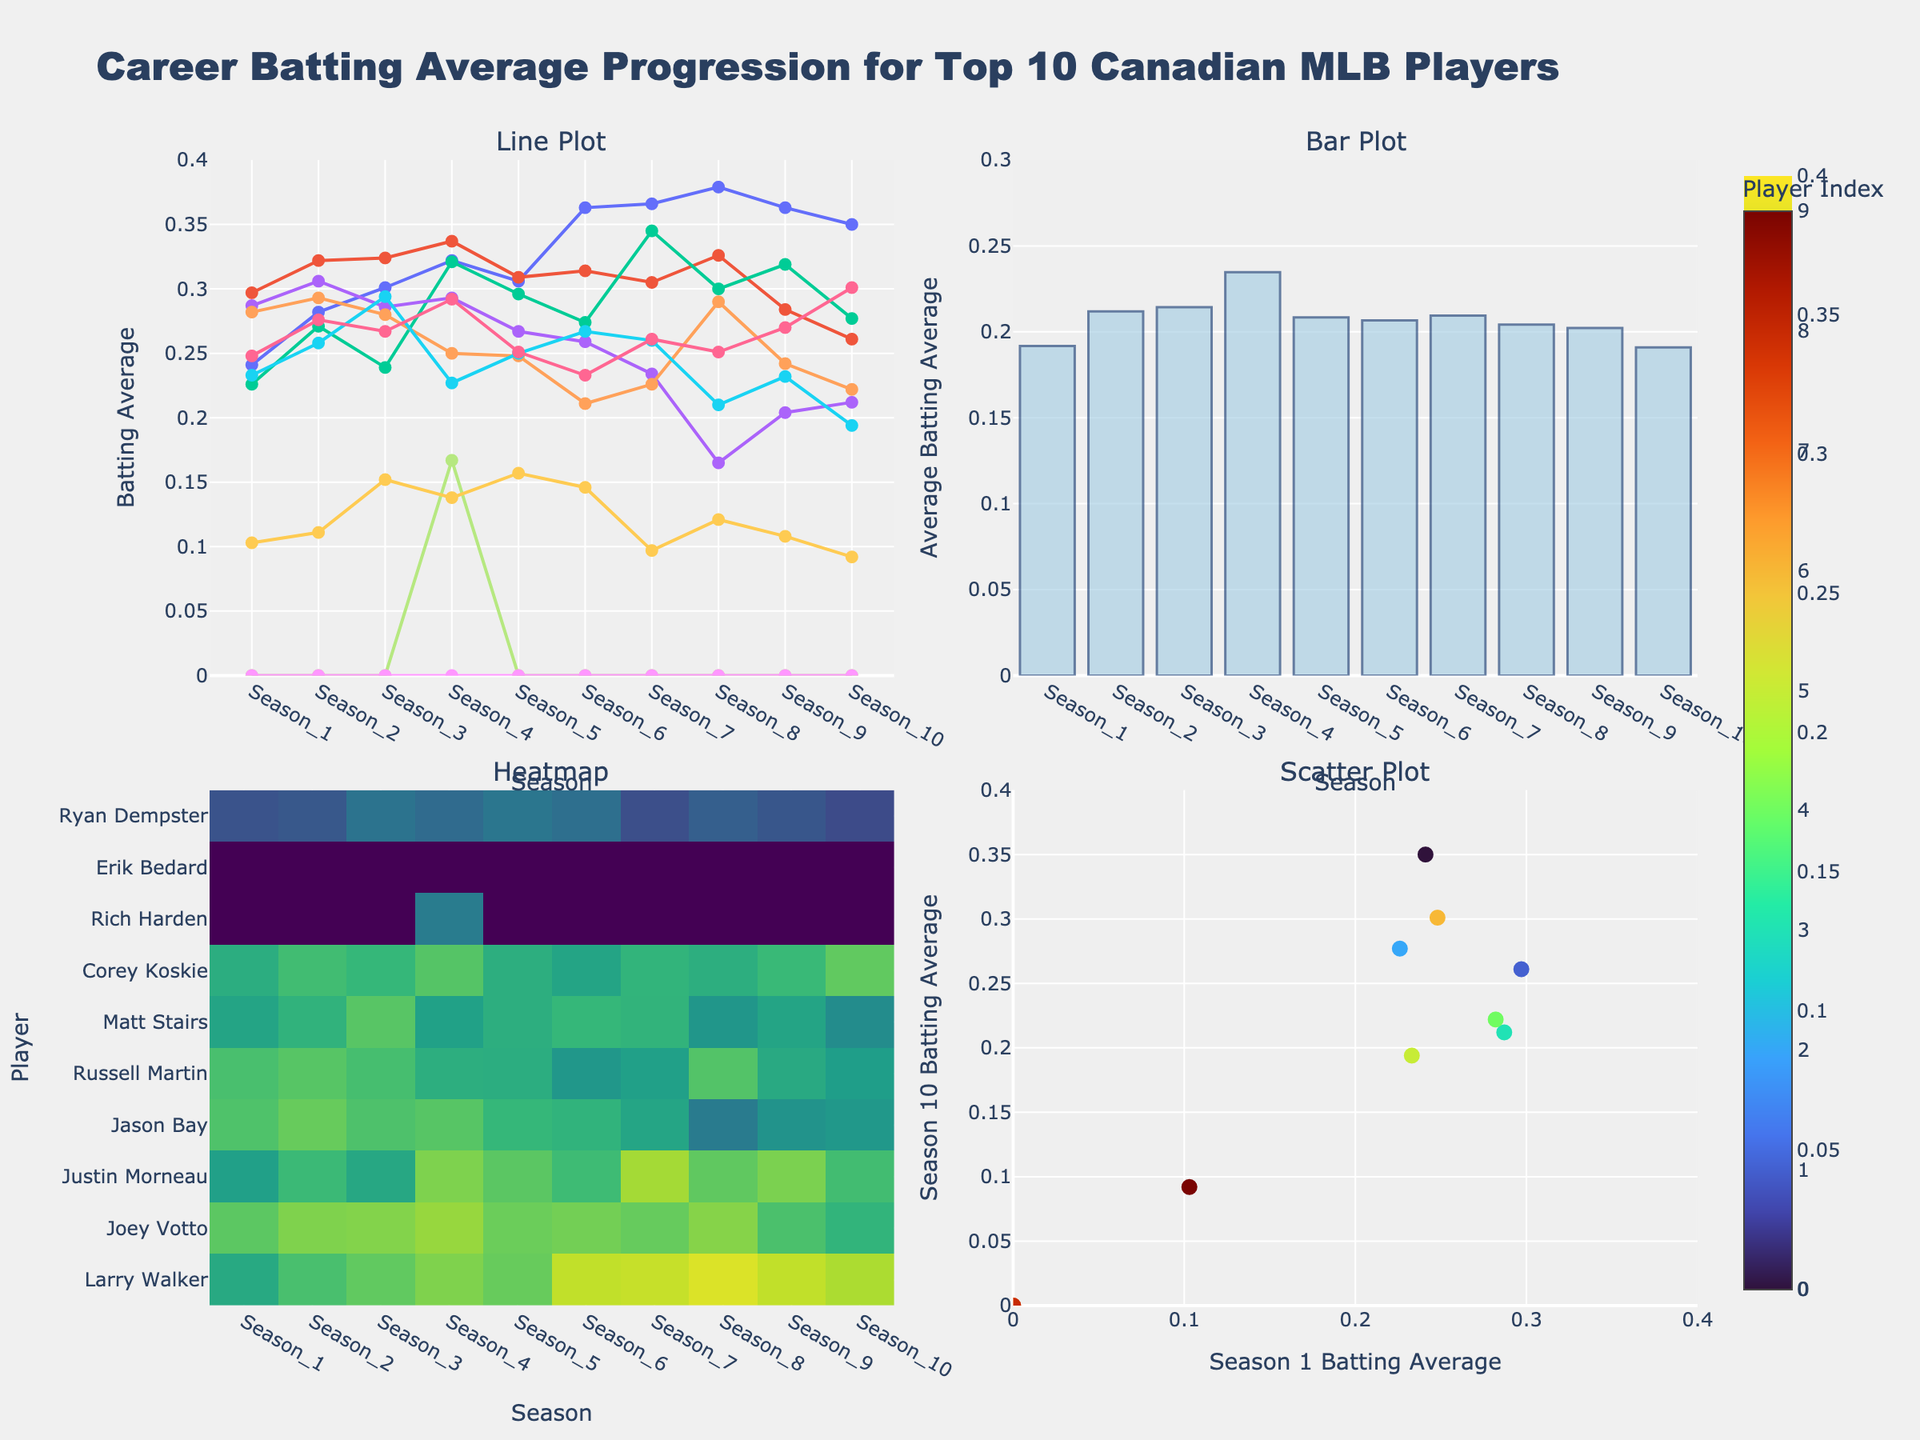What is the title of the figure? The title is typically displayed at the top of the figure, providing an overview of the content. In this case, it should be read directly from the plot.
Answer: Career Batting Average Progression for Top 10 Canadian MLB Players Which player has the highest batting average in Season 10 in the line plot? To determine this, look at the line plot's markers for Season 10 and identify the highest point.
Answer: Larry Walker What is the range of the y-axis in the bar plot? Examine the y-axis in the bar plot. The range is indicated by the minimum and maximum values marked on the axis.
Answer: 0 to 0.3 Which season has the highest average batting average across all players shown in the bar plot? Look at the bars in the bar plot, which represent average batting averages for each season. Identify which bar is the tallest.
Answer: Season 6 Between which seasons does Justin Morneau have the largest increase in his batting average as seen in the line plot? Check the line plot for Justin Morneau's line, then find the two seasons where the difference between consecutive points is the greatest.
Answer: Season 3 to Season 4 Who has the most consistent performance across seasons based on the heatmap? Consistency can be judged by identifying the player (y-axis) whose heatmap values (color intensity) change the least across different seasons (x-axis).
Answer: Joey Votto What is the batting average for Russell Martin in Season 5 as shown in the heatmap? Locate Russell Martin's row on the heatmap, then find the value corresponding to Season 5.
Answer: 0.248 How many players have a batting average of zero in the first season according to the scatter plot? In the scatter plot, check the points lying on the y-axis value (Season 1 batting average) and count how many are at zero.
Answer: 3 players Compare Larry Walker's and Jason Bay's performance in the scatter plot for Season 1 and Season 10. Who performs better overall? Find Larry Walker and Jason Bay's data points on the scatter plot, then check their values for both seasons. Larry Walker appears higher in both instances.
Answer: Larry Walker What is the color scheme used in the heatmap? The color scheme on the heatmap represents a range of values. Identify the color gradient used by examining the plot.
Answer: Viridis 